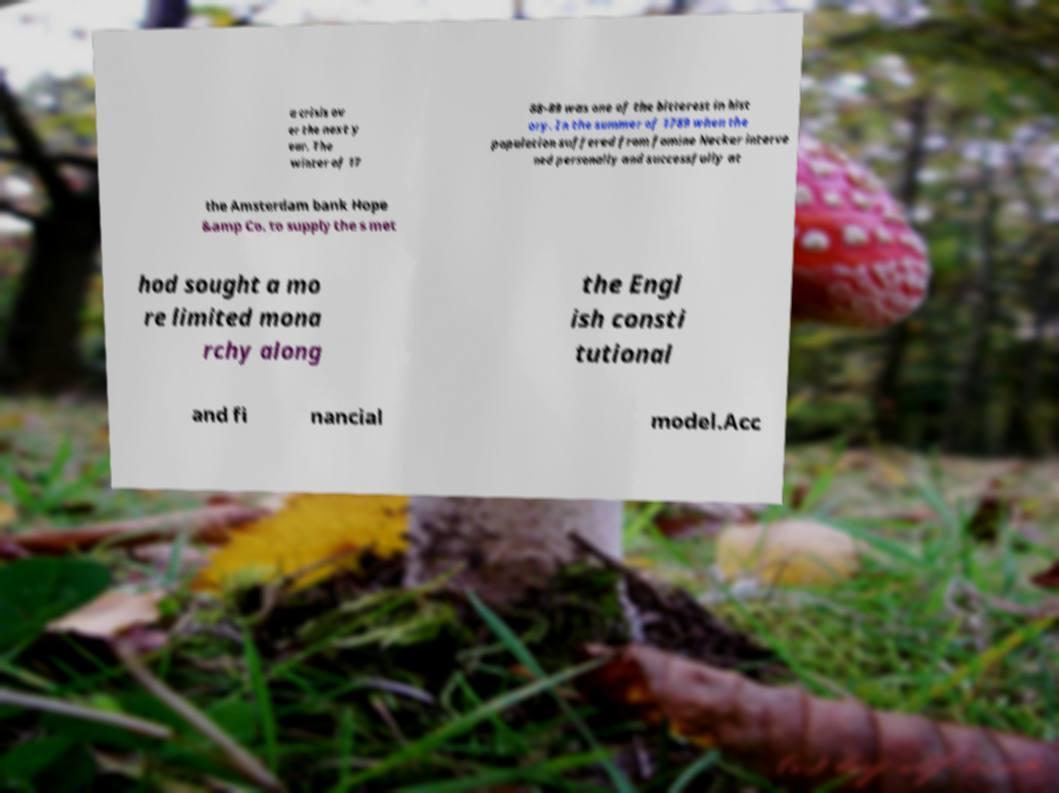Can you accurately transcribe the text from the provided image for me? a crisis ov er the next y ear. The winter of 17 88-89 was one of the bitterest in hist ory. In the summer of 1789 when the population suffered from famine Necker interve ned personally and successfully at the Amsterdam bank Hope &amp Co. to supply the s met hod sought a mo re limited mona rchy along the Engl ish consti tutional and fi nancial model.Acc 